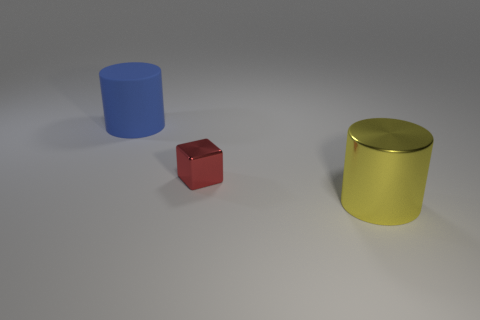Add 3 yellow cylinders. How many objects exist? 6 Subtract all cylinders. How many objects are left? 1 Add 1 red cubes. How many red cubes are left? 2 Add 3 blue cylinders. How many blue cylinders exist? 4 Subtract 0 cyan balls. How many objects are left? 3 Subtract all yellow matte balls. Subtract all tiny red blocks. How many objects are left? 2 